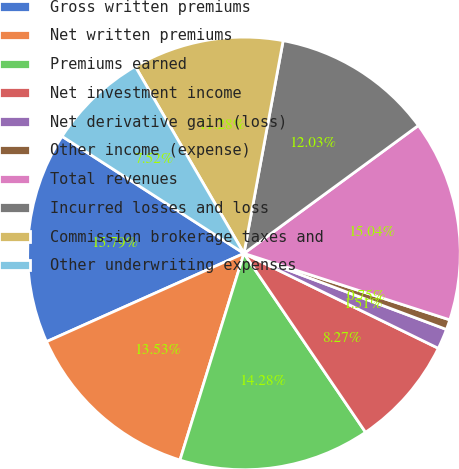Convert chart to OTSL. <chart><loc_0><loc_0><loc_500><loc_500><pie_chart><fcel>Gross written premiums<fcel>Net written premiums<fcel>Premiums earned<fcel>Net investment income<fcel>Net derivative gain (loss)<fcel>Other income (expense)<fcel>Total revenues<fcel>Incurred losses and loss<fcel>Commission brokerage taxes and<fcel>Other underwriting expenses<nl><fcel>15.79%<fcel>13.53%<fcel>14.28%<fcel>8.27%<fcel>1.51%<fcel>0.75%<fcel>15.04%<fcel>12.03%<fcel>11.28%<fcel>7.52%<nl></chart> 